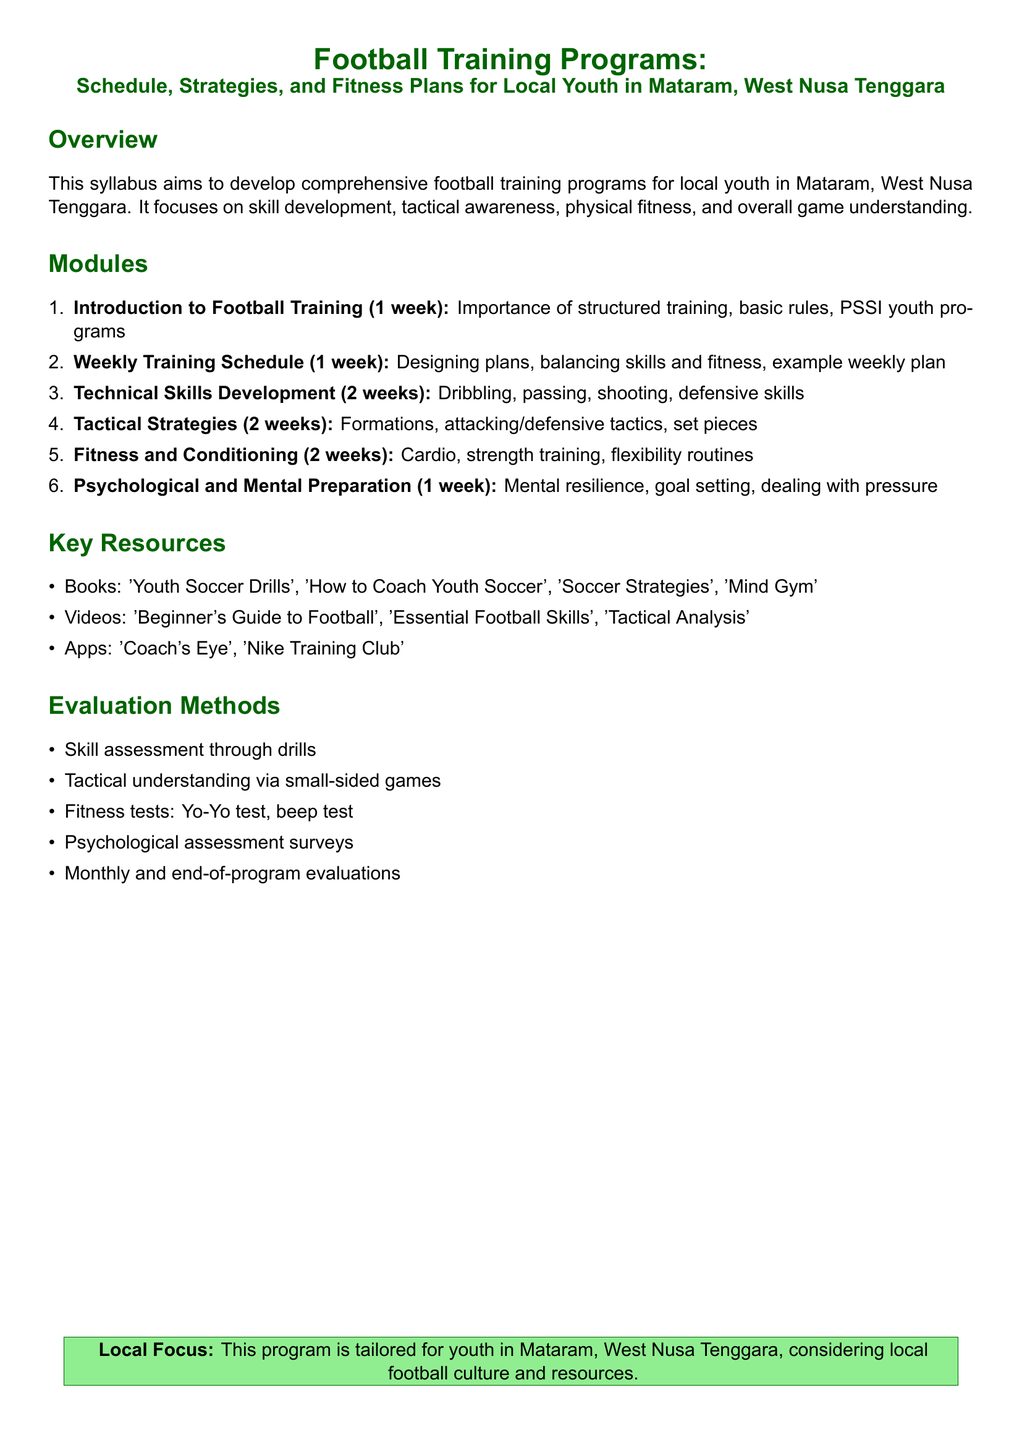What is the title of the syllabus? The title of the syllabus, as stated at the top, outlines the main topic and scope of the document.
Answer: Football Training Programs: Schedule, Strategies, and Fitness Plans for Local Youth in Mataram, West Nusa Tenggara How long is the Introduction to Football Training module? The duration of the module is explicitly mentioned in the syllabus outline.
Answer: 1 week What is one of the key resources mentioned in the syllabus? The syllabus lists various resources for training in a bullet format, indicating several options for reference.
Answer: 'Youth Soccer Drills' What is evaluated in the fitness tests? The syllabus specifies the types of evaluations to be conducted, particularly focusing on fitness tests.
Answer: Yo-Yo test, beep test How many weeks are dedicated to Technical Skills Development? The document specifies the duration for each training module, making it clear how long this particular focus lasts.
Answer: 2 weeks What is a focus area of the Fitness and Conditioning module? The module description provides insights into the specific fitness aspects that will be covered during this training.
Answer: Cardio What is the aim of the psychological assessment surveys? The document outlines evaluation methods, including surveys, implying their aim in assessing mental aspects.
Answer: Psychological evaluation How many total modules are included in the syllabus? The number of modules is counted based on the enumerated lists provided in the syllabus.
Answer: 6 modules 